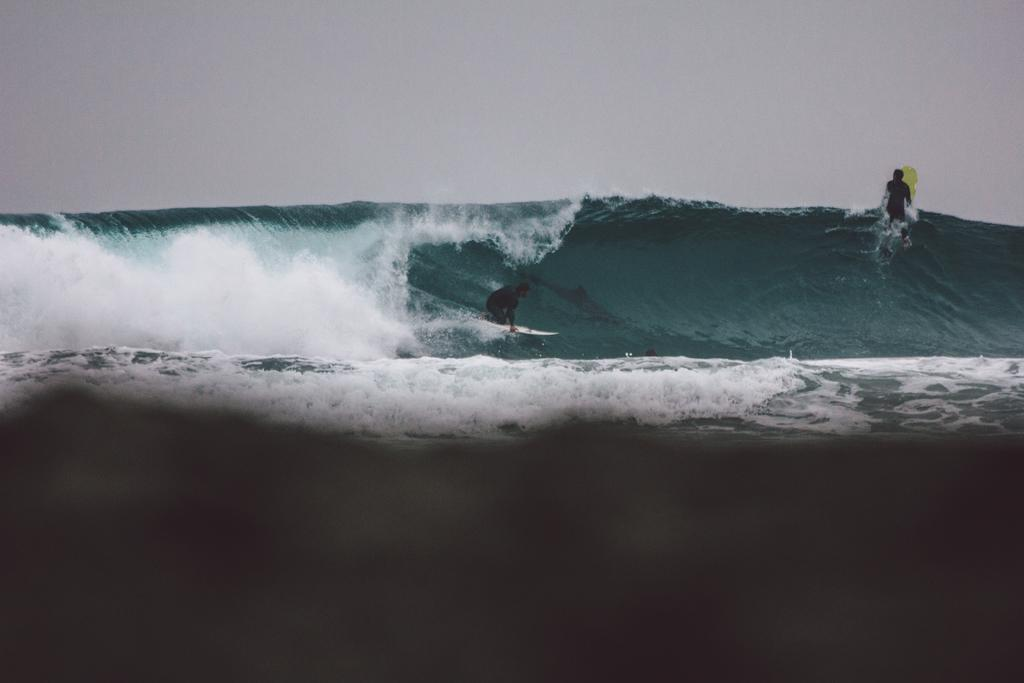How many people are in the image? There are two people in the image. What are the people doing in the image? The people are surfing on a water body. What is the condition of the sky in the image? The sky is clear in the image. Where can the hill be seen in the image? There is no hill present in the image; it features two people surfing on a water body with a clear sky. 